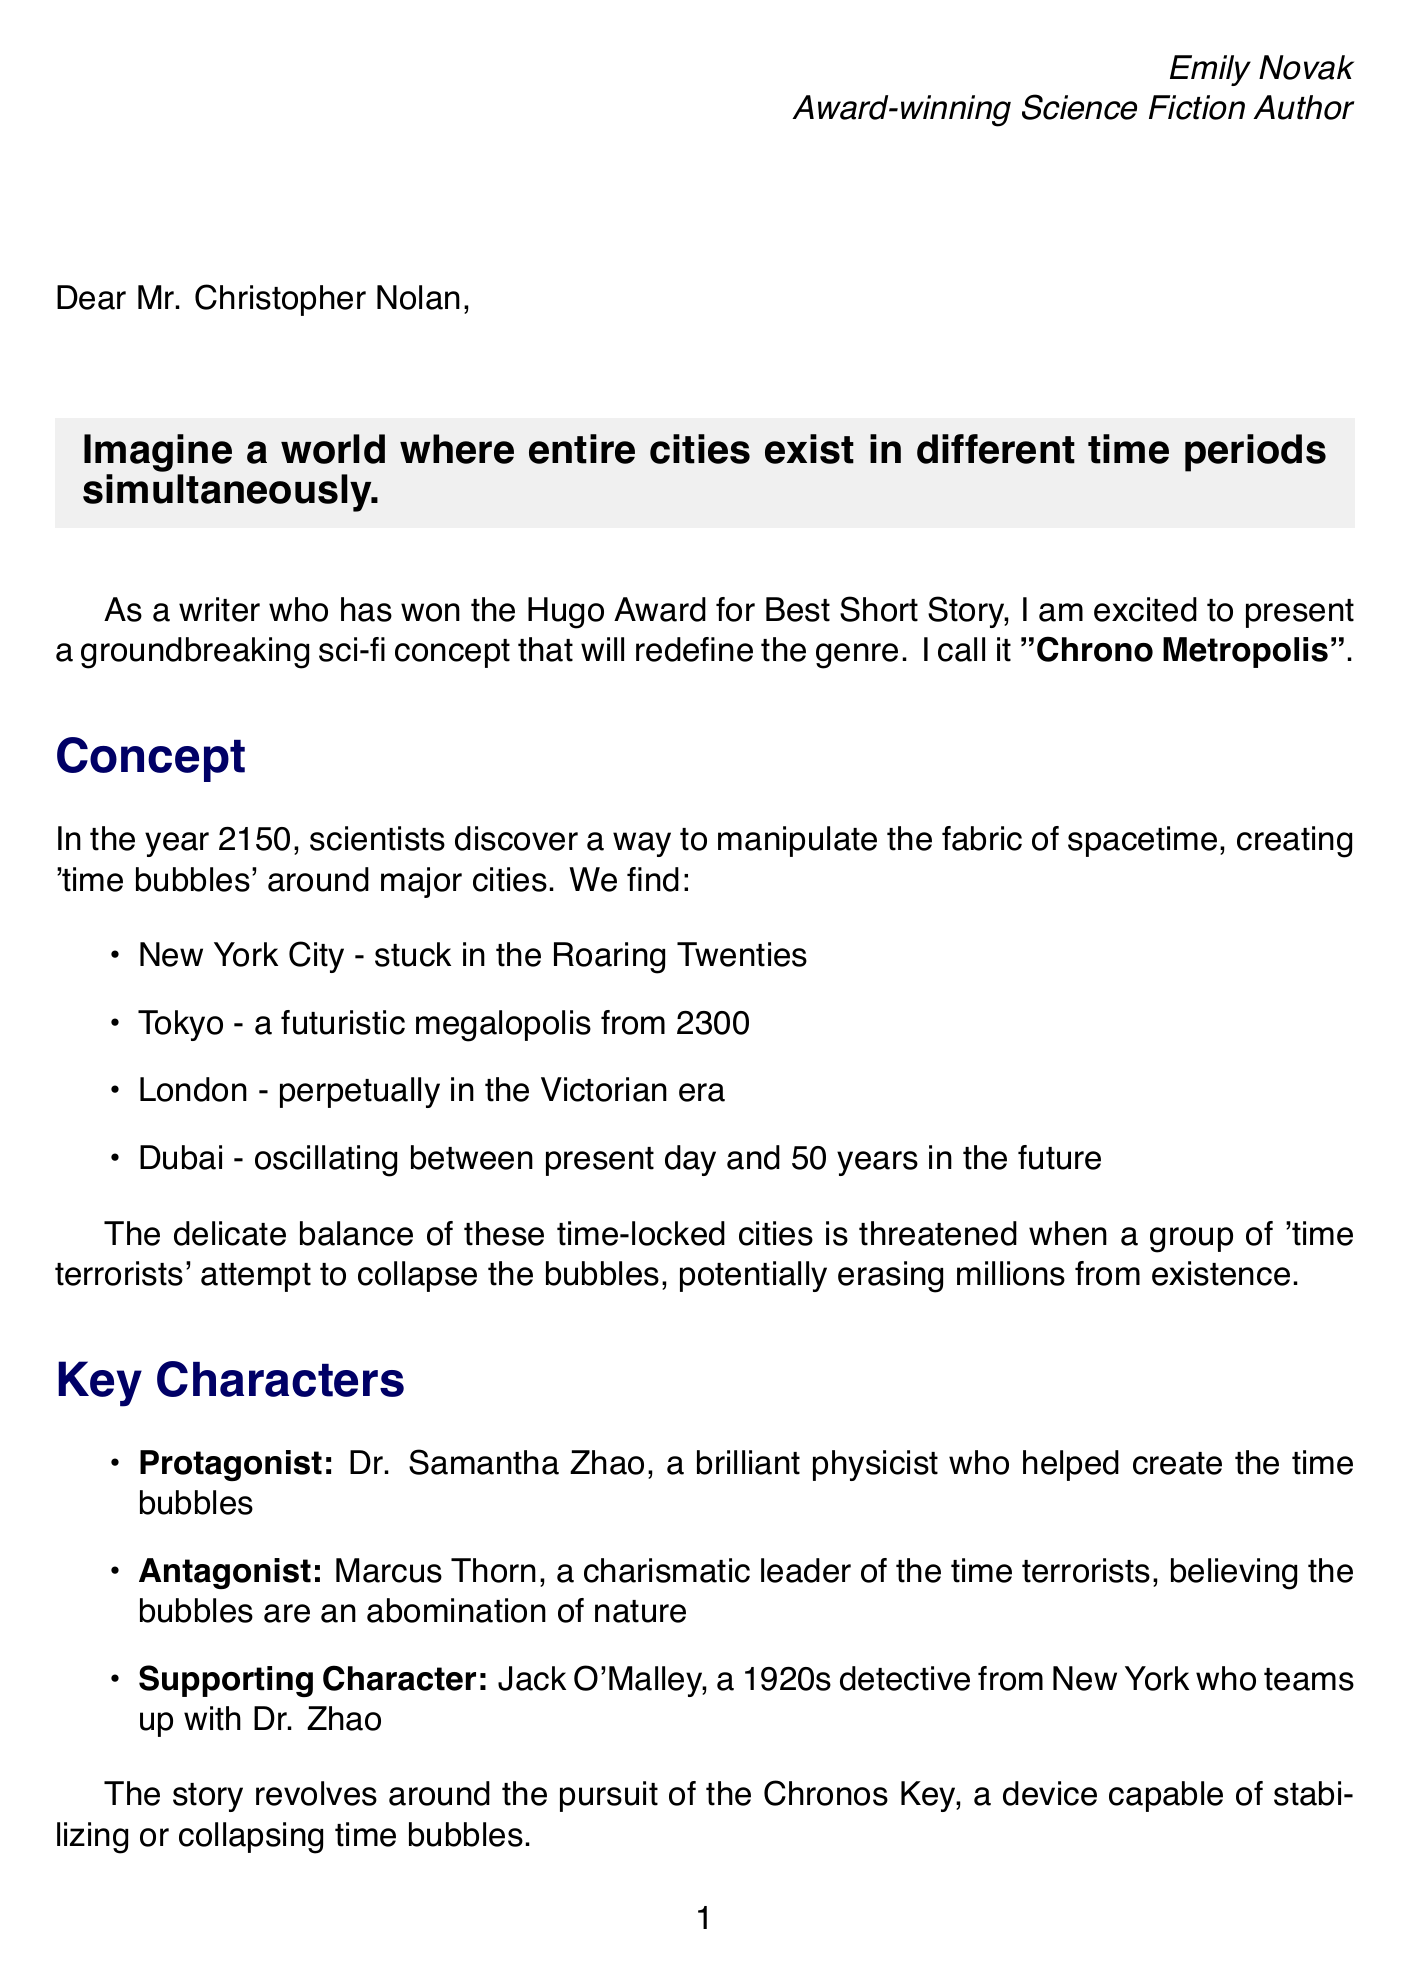What is the name of the concept being pitched? The name of the concept presented in the letter is explicitly mentioned as "Chrono Metropolis."
Answer: Chrono Metropolis Who is the protagonist of the story? The letter identifies Dr. Samantha Zhao as the protagonist who is a brilliant physicist.
Answer: Dr. Samantha Zhao What year do the events of the story take place? The document states that the story is set in the year 2150 when scientists discover time manipulation.
Answer: 2150 What is the estimated budget for the film? The budget for the production is stated as $200 million in the production considerations section.
Answer: $200 million Who is suggested as the director for the film? The letter recommends Denis Villeneuve as the suggested director for the project.
Answer: Denis Villeneuve What is the main conflict in the story? The main conflict revolves around 'time terrorists' attempting to collapse time bubbles, threatening millions.
Answer: Time terrorists What is the name of the device that can stabilize or collapse time bubbles? The device that plays a crucial role in the story is called the "Chronos Key."
Answer: Chronos Key What themes are explored in "Chrono Metropolis"? The document lists themes including the consequences of manipulating time and cultural preservation vs. progress.
Answer: Consequences of manipulating time, cultural preservation vs. progress What type of audience is this film targeting? The market potential section indicates that the film will appeal to fans of complex sci-fi like Inception and Interstellar.
Answer: Fans of complex sci-fi 